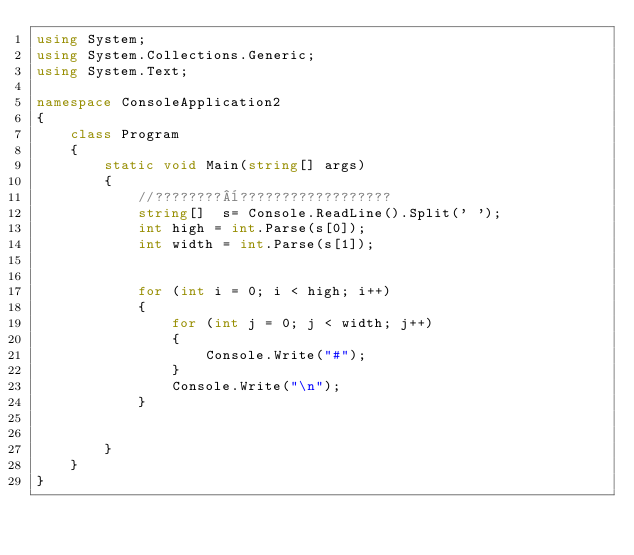Convert code to text. <code><loc_0><loc_0><loc_500><loc_500><_C#_>using System;
using System.Collections.Generic;
using System.Text;

namespace ConsoleApplication2
{
    class Program
    {
        static void Main(string[] args)
        {
            //????????¨??????????????????
            string[]  s= Console.ReadLine().Split(' ');
            int high = int.Parse(s[0]);
            int width = int.Parse(s[1]);


            for (int i = 0; i < high; i++)
            {
                for (int j = 0; j < width; j++)
                {
                    Console.Write("#");
                }
                Console.Write("\n");
            }

            
        }
    }
}</code> 